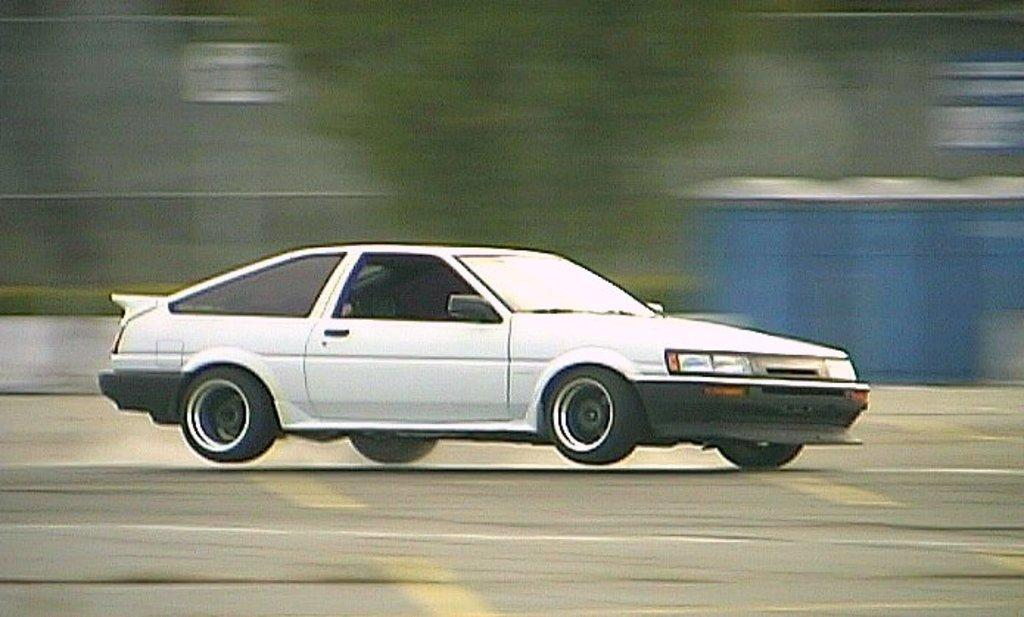What is the main subject of the image? The main subject of the image is a car. Where is the car located in the image? The car is on the road in the image. What type of question is being asked by the plants in the image? There are no plants present in the image, and therefore no questions are being asked by plants. 